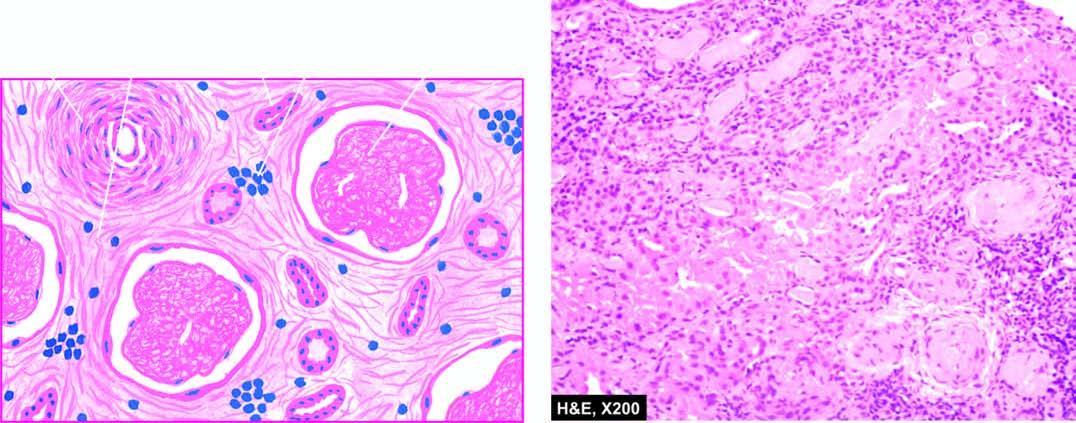what does the interstitium show?
Answer the question using a single word or phrase. Fine fibrosis and a few chronic inflammatory cells 